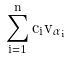Convert formula to latex. <formula><loc_0><loc_0><loc_500><loc_500>\sum _ { i = 1 } ^ { n } c _ { i } v _ { \alpha _ { i } }</formula> 